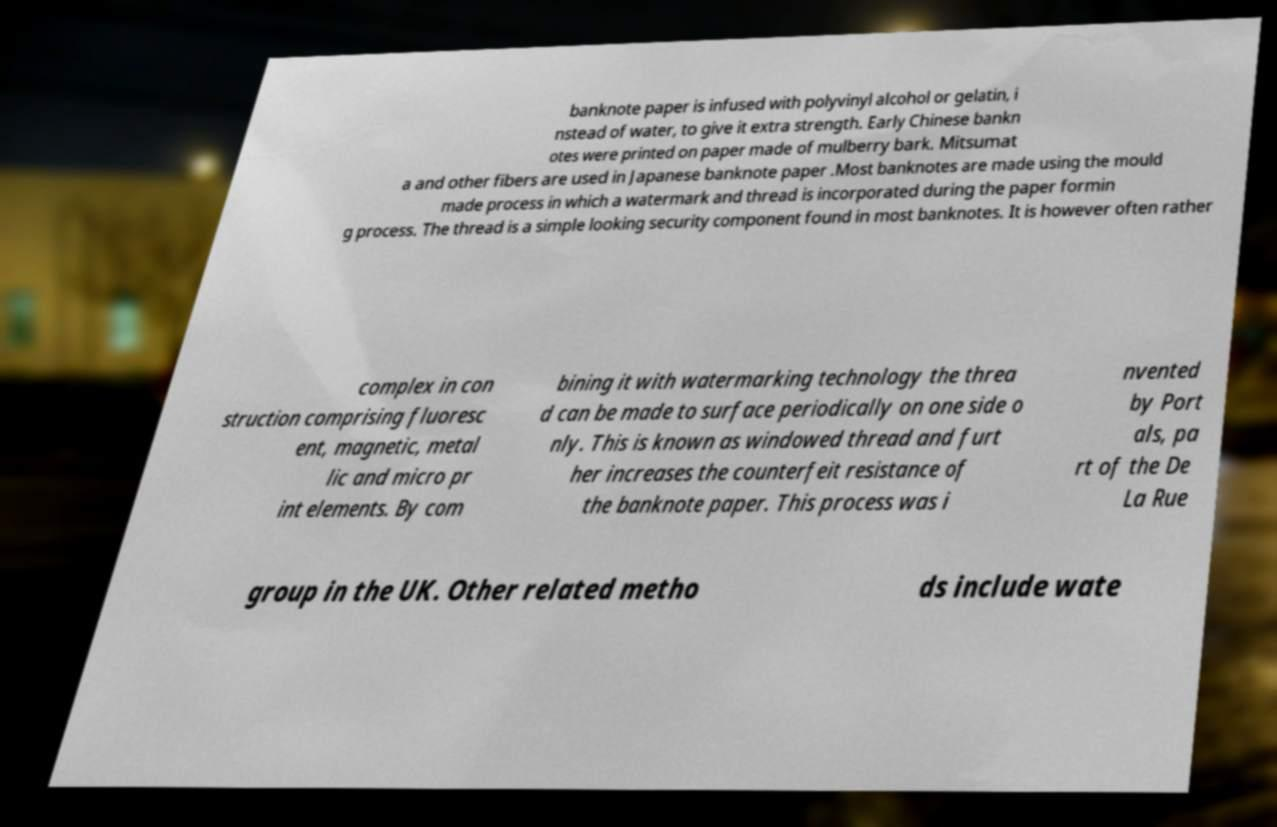For documentation purposes, I need the text within this image transcribed. Could you provide that? banknote paper is infused with polyvinyl alcohol or gelatin, i nstead of water, to give it extra strength. Early Chinese bankn otes were printed on paper made of mulberry bark. Mitsumat a and other fibers are used in Japanese banknote paper .Most banknotes are made using the mould made process in which a watermark and thread is incorporated during the paper formin g process. The thread is a simple looking security component found in most banknotes. It is however often rather complex in con struction comprising fluoresc ent, magnetic, metal lic and micro pr int elements. By com bining it with watermarking technology the threa d can be made to surface periodically on one side o nly. This is known as windowed thread and furt her increases the counterfeit resistance of the banknote paper. This process was i nvented by Port als, pa rt of the De La Rue group in the UK. Other related metho ds include wate 